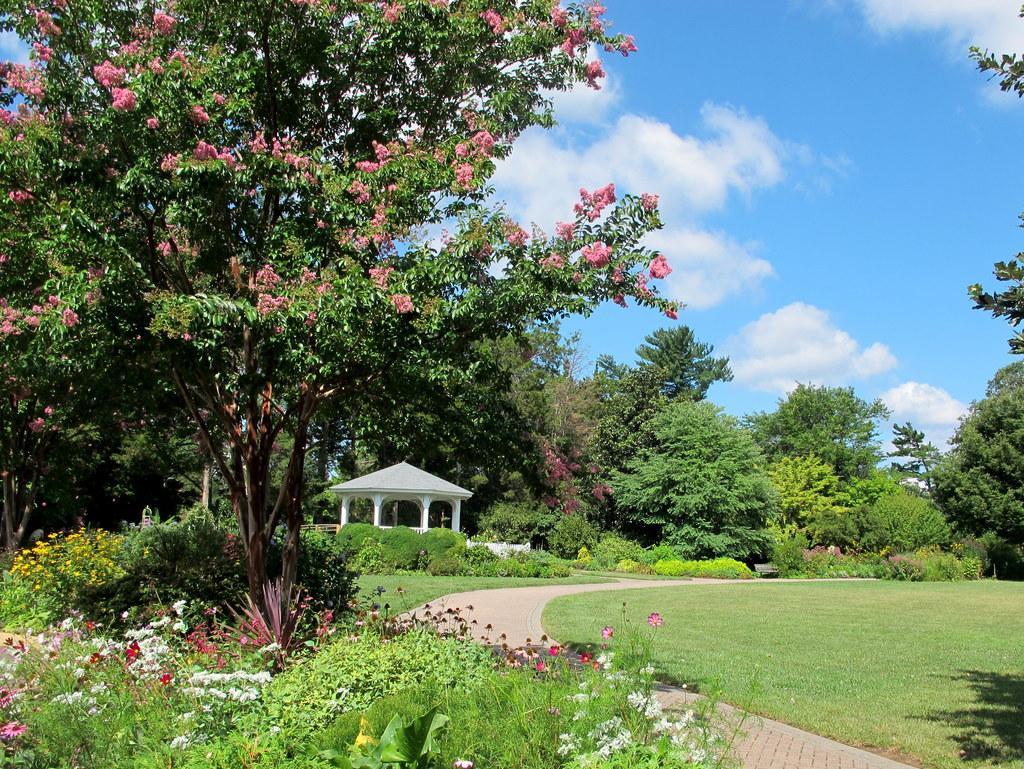Can you describe this image briefly? In this image there is a rock structure, around the rock structure, there are trees, plants, flowers and the surface of the grass. In the background there is the sky. 